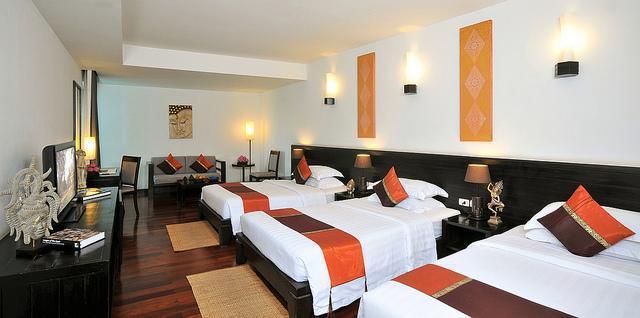In what continent is this hotel likely to be located?
Answer the question by selecting the correct answer among the 4 following choices.
Options: Asia, africa, europe, north america. Asia. 